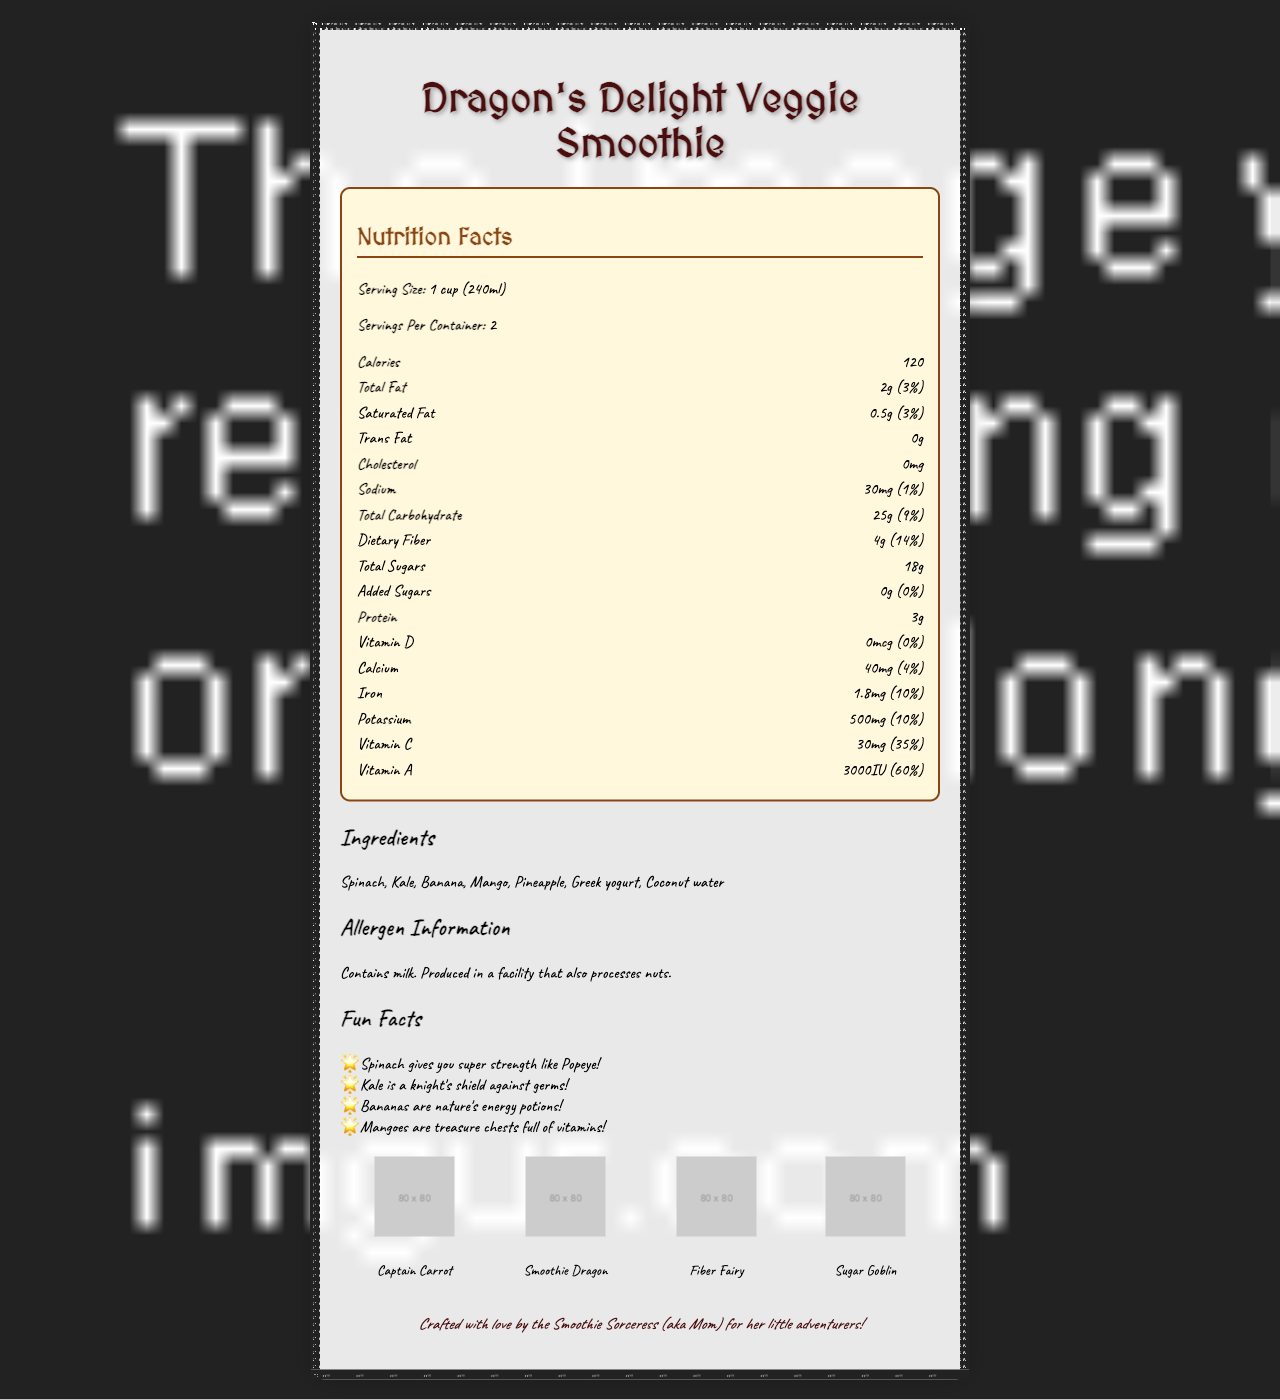How many servings are in one container of Dragon's Delight Veggie Smoothie? The document states that there are 2 servings per container.
Answer: 2 What is the serving size of the smoothie? The document lists the serving size as 1 cup (240ml).
Answer: 1 cup (240ml) How much dietary fiber is in one serving of the smoothie? The document specifies that there are 4g of dietary fiber per serving.
Answer: 4g Which vitamin has the highest daily value percentage in the smoothie? The document shows that Vitamin A has a daily value percentage of 60%, which is higher than other vitamins listed.
Answer: Vitamin A Is this smoothie free from added sugars? The document notes that there are 0g of added sugars, which means it is free from added sugars.
Answer: Yes How much protein does one serving of the smoothie contain? The document notes that there are 3g of protein per serving.
Answer: 3g What are the main ingredients in the smoothie? The ingredients list in the document includes Spinach, Kale, Banana, Mango, Pineapple, Greek yogurt, and Coconut water.
Answer: Spinach, Kale, Banana, Mango, Pineapple, Greek yogurt, Coconut water Which playful character indicates the smoothie has no added sugars? A. Captain Carrot B. Smoothie Dragon C. Fiber Fairy D. Sugar Goblin The document describes the Sugar Goblin as having a 'no entry' sign indicating no added sugars.
Answer: D What is the main message of the "mom approved" section? The document ends with this message as the "mom approved" section, indicating that the smoothie is made with love for children.
Answer: Crafted with love by the Smoothie Sorceress (aka Mom) for her little adventurers! Which of the following is not mentioned as an ingredient of the smoothie? A. Banana B. Apple C. Pineapple D. Kale The ingredients list does not include Apple, therefore the correct answer is Apple.
Answer: B Is there any cholesterol in the smoothie? The document lists 0mg of cholesterol in the smoothie.
Answer: No What are some fun facts mentioned about the ingredients? The document includes fun facts such as "Spinach gives you super strength like Popeye," "Kale is a knight's shield against germs," "Bananas are nature's energy potions," and "Mangoes are treasure chests full of vitamins."
Answer: Spinach gives you super strength like Popeye, Kale is a knight's shield against germs, Bananas are nature's energy potions, Mangoes are treasure chests full of vitamins What kind of design elements are used in the smoothie label? The document features design elements like a medieval scroll with a dragon scale pattern for the border, an enchanted forest background with hidden vegetables, and playful fonts such as Ye Olde RPG for headings and Pixie Script for details.
Answer: Medieval scroll with dragon scale pattern for the border, enchanted forest with hidden vegetables for the background, and playful fonts like Ye Olde RPG for headings and Pixie Script for details Who created the smoothie according to the document? The document notes that the smoothie is crafted with love by the Smoothie Sorceress, also known as Mom.
Answer: The Smoothie Sorceress (aka Mom) How much calcium is in one serving of the smoothie? The document lists 40mg of calcium per serving.
Answer: 40mg What is the total amount of sugars in the smoothie? The document specifies that one serving of the smoothie contains 18g of total sugars.
Answer: 18g How much potassium is in one serving of the smoothie? The document states that there are 500mg of potassium per serving.
Answer: 500mg Which character is described as sprinkling fiber sparkles over the label? The document describes the Fiber Fairy as the character sprinkling fiber sparkles over the label.
Answer: Fiber Fairy Describe the entire document. The document is a playful, informative label that combines essential nutritional information with creative and engaging elements to appeal to both children and their parents.
Answer: The document is a nutrition facts label for "Dragon's Delight Veggie Smoothie," which uses playful RPG-inspired fonts and illustrations to make healthy eating fun for kids. It provides detailed nutritional information for a serving size of 1 cup (240ml), with each container holding 2 servings. Key nutritional data includes 120 calories per serving, 4g of dietary fiber, and an absence of added sugars. The ingredients list features Spinach, Kale, Banana, Mango, Pineapple, Greek yogurt, and Coconut water. Fun facts about the ingredients are included, alongside allergen information noting it contains milk and is produced in a facility that processes nuts. Playful characters like Captain Carrot and Sugar Goblin add a whimsical touch, and the document includes a heartfelt message from the creator, referred to as the Smoothie Sorceress (aka Mom). Does the smoothie contain any tree nuts? The allergen information section mentions that the product is produced in a facility that also processes nuts, but it doesn't specify whether the smoothie itself contains tree nuts.
Answer: Not enough information 